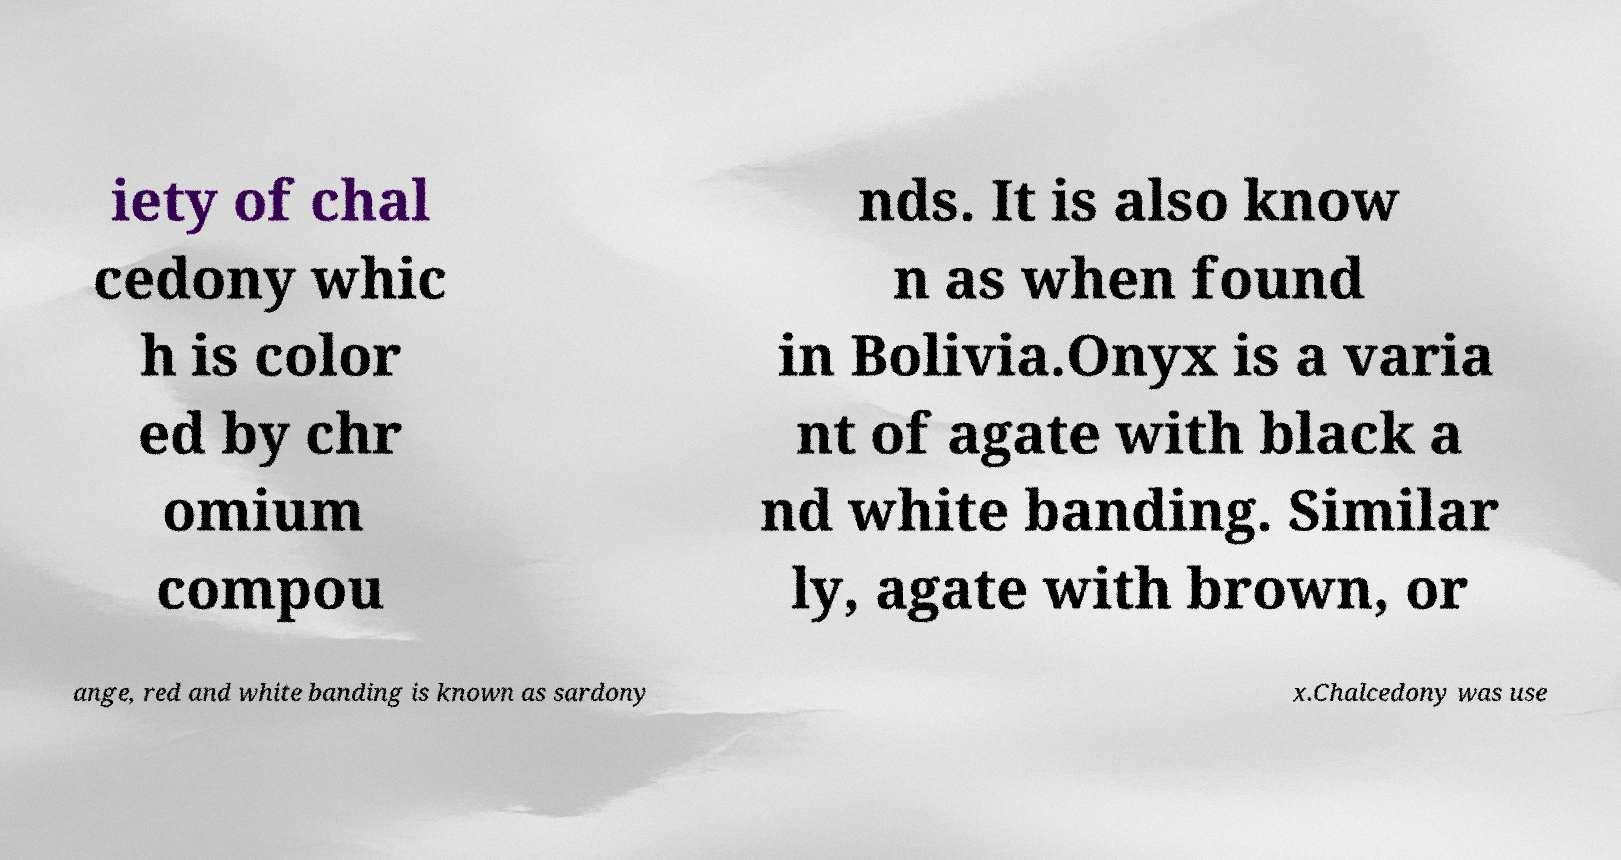Please identify and transcribe the text found in this image. iety of chal cedony whic h is color ed by chr omium compou nds. It is also know n as when found in Bolivia.Onyx is a varia nt of agate with black a nd white banding. Similar ly, agate with brown, or ange, red and white banding is known as sardony x.Chalcedony was use 